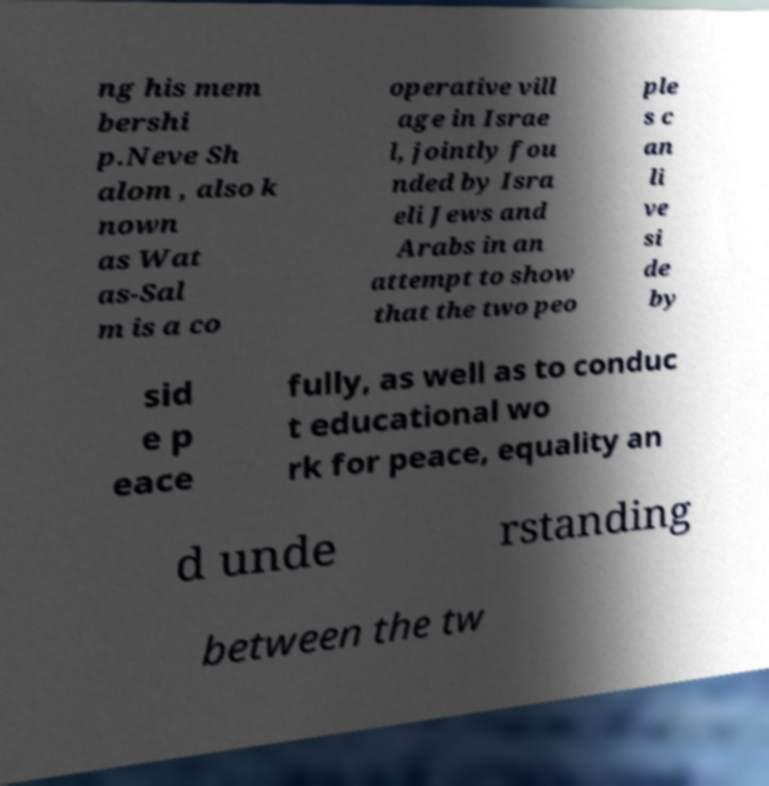Can you accurately transcribe the text from the provided image for me? ng his mem bershi p.Neve Sh alom , also k nown as Wat as-Sal m is a co operative vill age in Israe l, jointly fou nded by Isra eli Jews and Arabs in an attempt to show that the two peo ple s c an li ve si de by sid e p eace fully, as well as to conduc t educational wo rk for peace, equality an d unde rstanding between the tw 